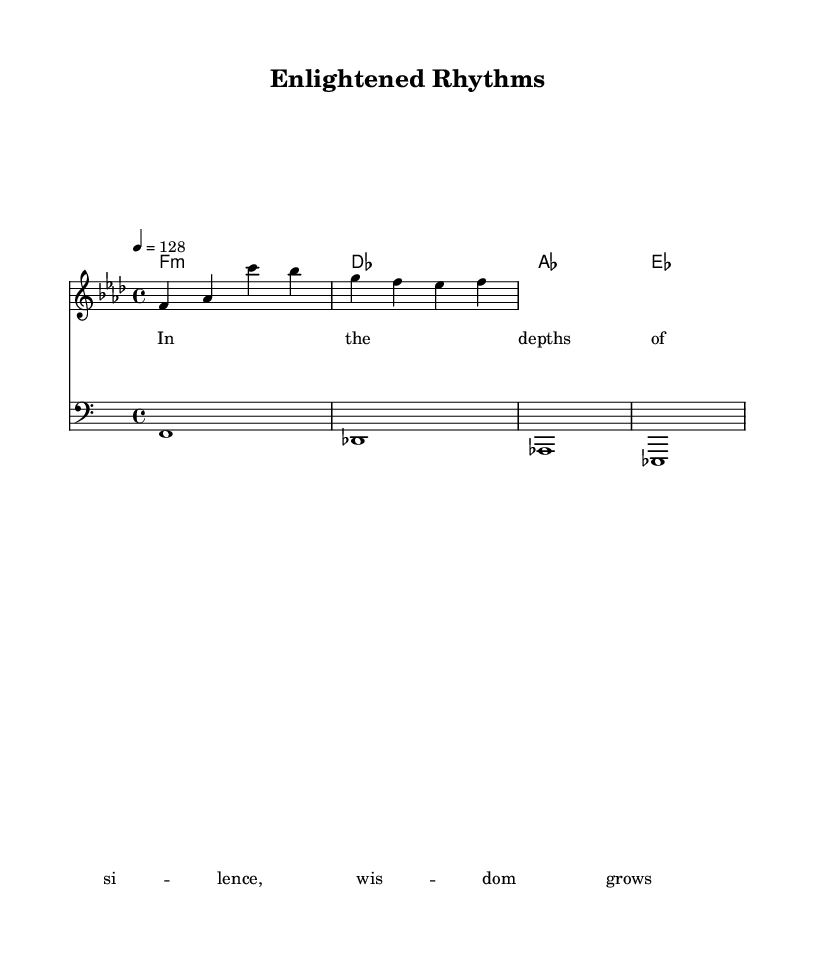What is the key signature of this music? The key signature is identified by the presence of four flats, which indicates that the piece is in F minor.
Answer: F minor What is the time signature of this music? The time signature is indicated at the beginning of the score as 4/4, meaning there are four beats in each measure, and the quarter note receives one beat.
Answer: 4/4 What is the tempo of this piece? The tempo marking specifies "4 = 128," meaning the quarter note is played at a speed of 128 beats per minute.
Answer: 128 What is the root chord of the first measure? The root chord is shown in the chord names section at the beginning of the first measure, which is F minor (f1:m).
Answer: F minor Why is the bass clef used in this piece? The bass clef is utilized to indicate lower pitch sounds, which is typical in house music for establishing a groove; it effectively complements the harmony and melody.
Answer: To indicate lower pitches What is the main theme expressed in the lyrics? The lyrics suggest introspection and the growth of wisdom within silence, aligning with the teachings of Pt. Shriram Sharma Acharya about self-discovery and enlightenment.
Answer: Wisdom grows 